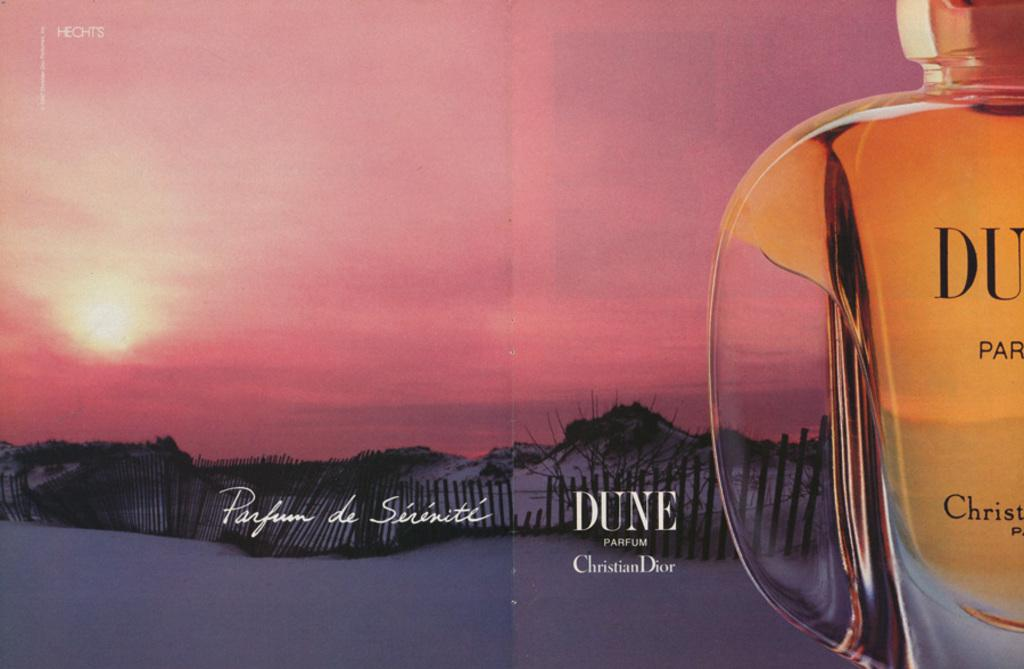<image>
Summarize the visual content of the image. A picture of the sun in the background is the set for a Dune perfume advertisement. 